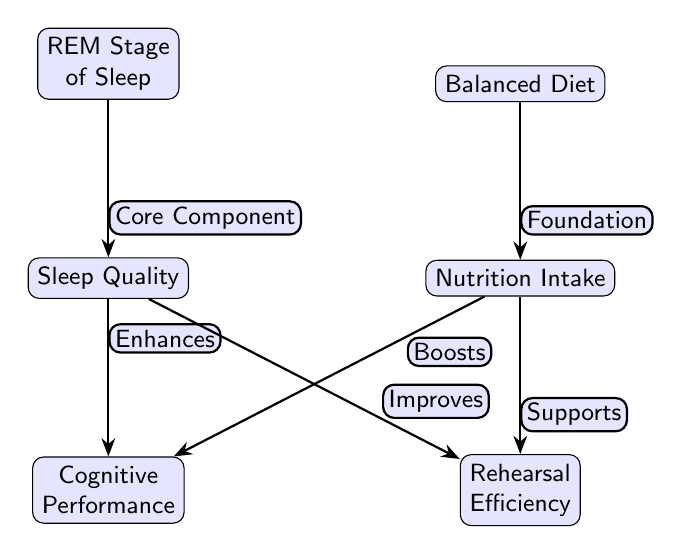What are the two primary factors affecting cognitive performance? The diagram indicates that the two primary factors affecting cognitive performance are "Sleep Quality" and "Nutrition Intake," as both nodes directly connect to "Cognitive Performance."
Answer: Sleep Quality and Nutrition Intake What does sleep quality enhance? According to the diagram, "Sleep Quality" enhances "Cognitive Performance," as denoted by the directed edge labeled "Enhances."
Answer: Cognitive Performance How many edges connect to rehearsal efficiency? In the diagram, "Rehearsal Efficiency" has two incoming edges, one from "Sleep Quality" and another from "Nutrition Intake," which makes the total count of edges to this node equal to two.
Answer: Two What stage of sleep is identified as a core component? The diagram specifies the "REM Stage of Sleep" as a core component related to "Sleep Quality," indicated by the edge labeled "Core Component."
Answer: REM Stage of Sleep Which diet supports nutrition intake? The "Balanced Diet" is indicated as providing foundational support to "Nutrition Intake," as reflected by the label "Foundation" on the connecting edge.
Answer: Balanced Diet Which factor improves rehearsal efficiency? In the diagram, "Sleep Quality" is marked to improve "Rehearsal Efficiency," as noted by the edge labeled "Improves."
Answer: Sleep Quality What type of diagram is this? This diagram is categorized as a Biomedical Diagram, focusing on the effects of sleep and nutrition on cognitive and rehearsal performance.
Answer: Biomedical Diagram How many nodes are in the diagram? The diagram features six nodes: "Sleep Quality," "Nutrition Intake," "Cognitive Performance," "Rehearsal Efficiency," "REM Stage of Sleep," and "Balanced Diet," totaling six nodes.
Answer: Six 